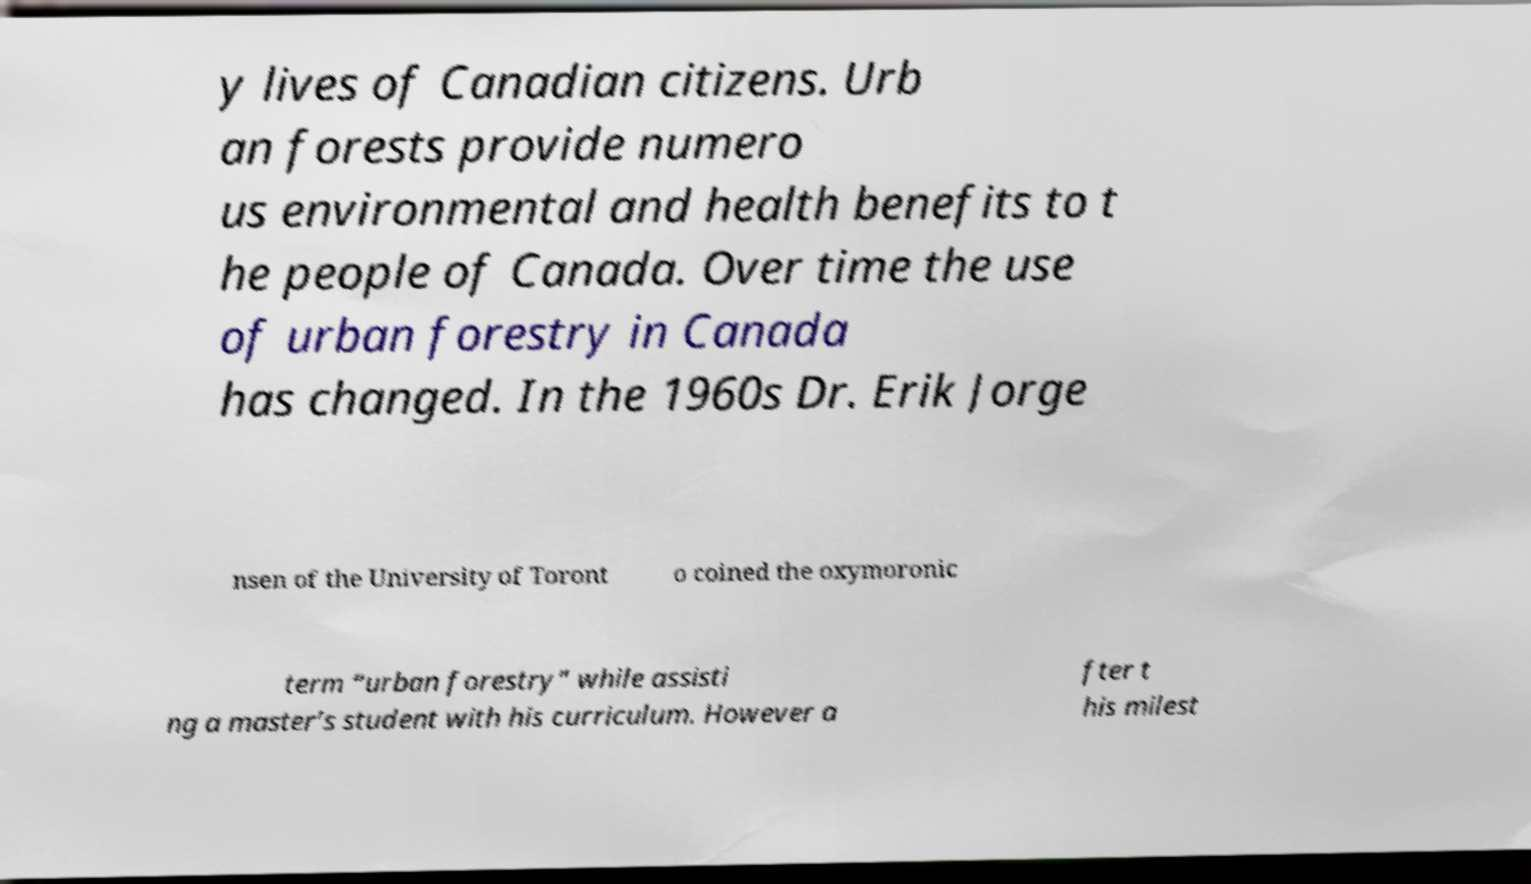For documentation purposes, I need the text within this image transcribed. Could you provide that? y lives of Canadian citizens. Urb an forests provide numero us environmental and health benefits to t he people of Canada. Over time the use of urban forestry in Canada has changed. In the 1960s Dr. Erik Jorge nsen of the University of Toront o coined the oxymoronic term “urban forestry” while assisti ng a master’s student with his curriculum. However a fter t his milest 